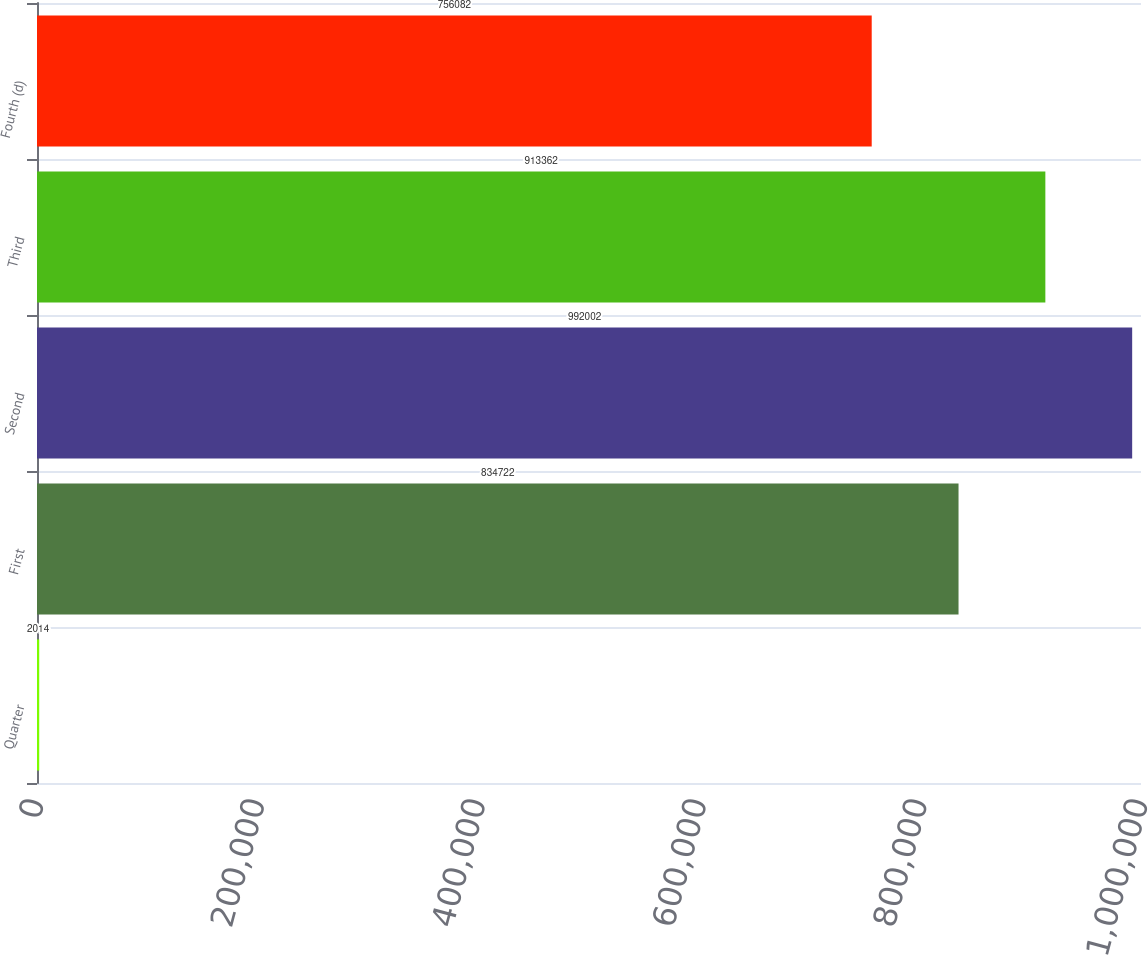<chart> <loc_0><loc_0><loc_500><loc_500><bar_chart><fcel>Quarter<fcel>First<fcel>Second<fcel>Third<fcel>Fourth (d)<nl><fcel>2014<fcel>834722<fcel>992002<fcel>913362<fcel>756082<nl></chart> 